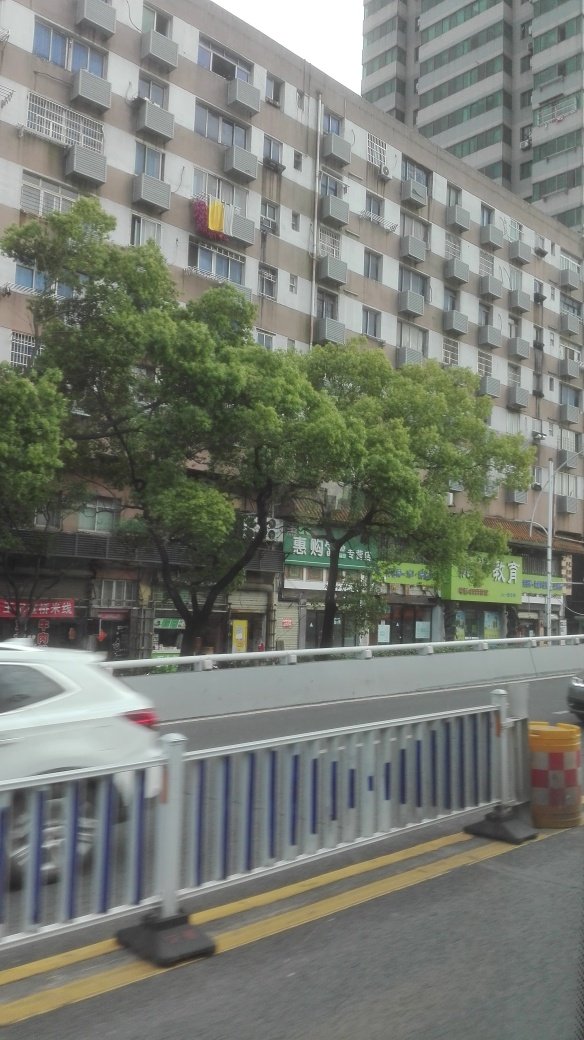What are some of the human activities that might happen in this area? In this urban environment, one might expect activities such as shopping at the ground-level stores, residential living in the apartments above, and commuting along the road near the protective barrier. It's likely a place where locals engage in daily routines like going to work or school, socializing, and running errands. What suggests that this image was taken during a commute? The angle and motion blur suggest that the photo was taken from a moving vehicle, possibly someone commuting. The presence of guardrails and blurred edges of a white car in the frame also reinforces the notion that this scene is viewed from the road. 